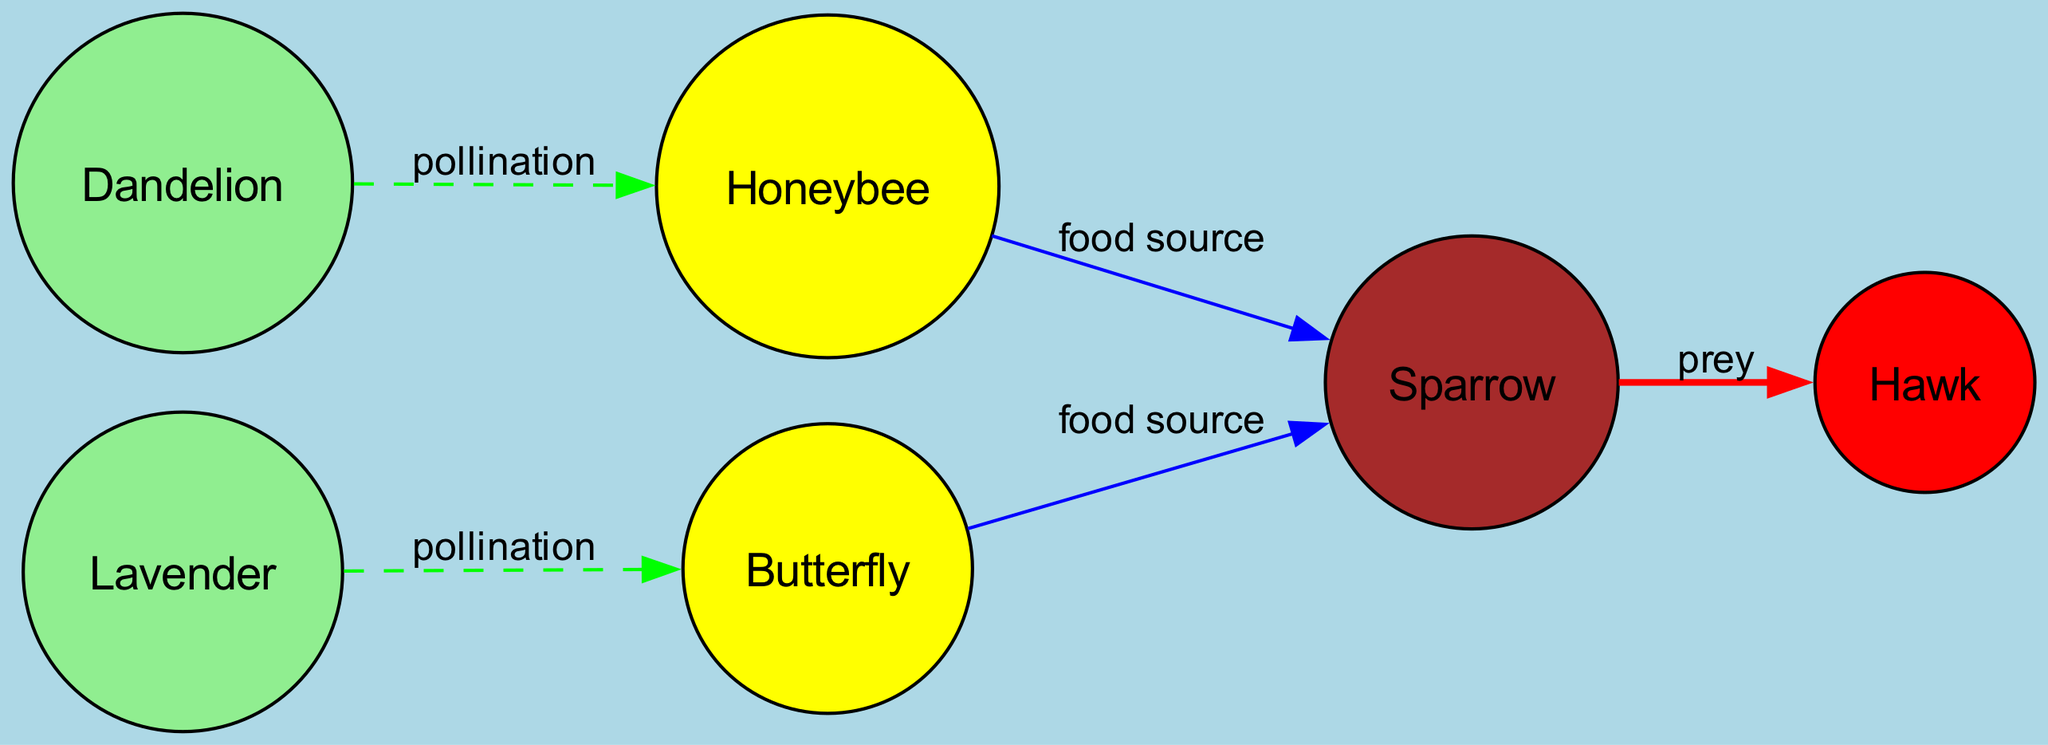What is the total number of nodes in the diagram? The diagram contains 6 nodes, which are Dandelion, Lavender, Honeybee, Butterfly, Sparrow, and Hawk. Each of these corresponds to a specific entity in the pollination network.
Answer: 6 How many edges represent the relationship of "pollination"? The diagram has 2 edges labeled "pollination," connecting Dandelion to Honeybee and Lavender to Butterfly, showing the plants' relationships with their pollinators.
Answer: 2 Which plants are included in the diagram? The diagram shows two plants: Dandelion and Lavender, both of which are nodes in the network and connected to their respective pollinators.
Answer: Dandelion, Lavender What kind of relationship exists between Honeybee and Sparrow? Honeybee is connected to Sparrow by the edge labeled "food source," indicating that Sparrow feeds on Honeybee in this food chain.
Answer: food source Which animal is at the top of the food chain? The diagram shows Hawk at the top, as it preys on Sparrow, establishing its position as the apex predator in this ecological network.
Answer: Hawk How many different types of relationships are represented in the edges of the diagram? There are 2 different types of relationships represented in the diagram: "pollination" and "food source," with an additional one, "prey," for the connection between Sparrow and Hawk.
Answer: 3 Which pollinator is associated with Dandelion? The edge indicates that Honeybee is associated with Dandelion through the relationship labeled "pollination," showing the specific connection.
Answer: Honeybee What color represents pollination relationships in the diagram? The edges represent the "pollination" relationships in green, differentiating them visually from other types of connections in the network.
Answer: green Which two organisms share a food source relationship with Sparrow? Both Honeybee and Butterfly provide a food source for Sparrow, as indicated by the edges leading from these pollinators to Sparrow in the diagram.
Answer: Honeybee, Butterfly 